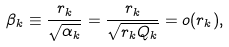Convert formula to latex. <formula><loc_0><loc_0><loc_500><loc_500>\beta _ { k } \equiv \frac { r _ { k } } { \sqrt { \alpha _ { k } } } = \frac { r _ { k } } { \sqrt { r _ { k } Q _ { k } } } = o ( r _ { k } ) ,</formula> 